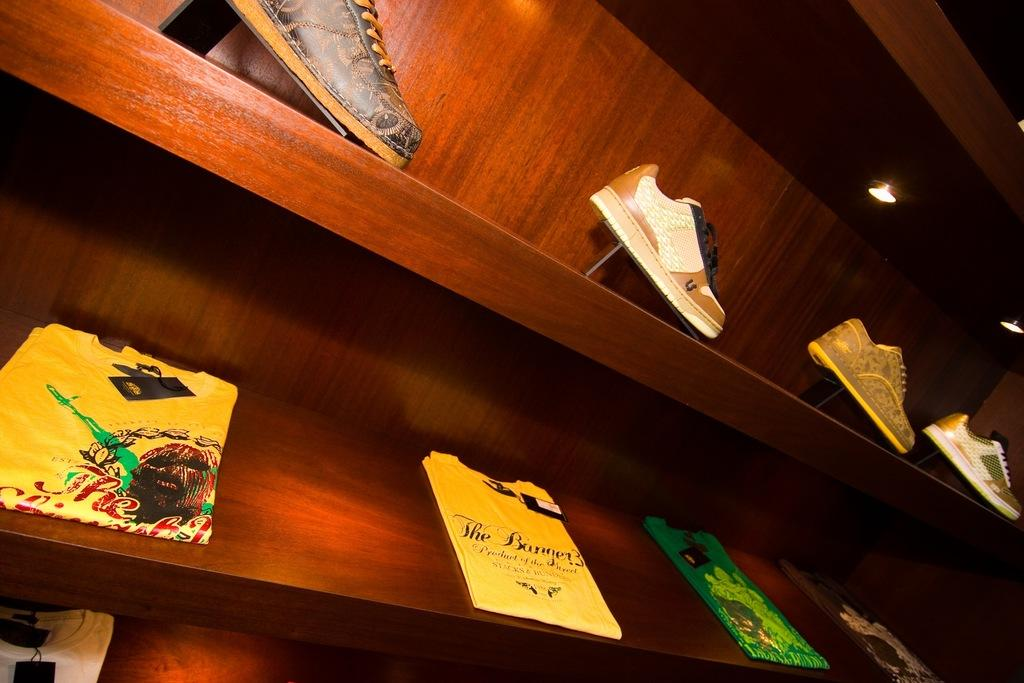What is the main object in the image? There is a rack in the image. What is stored on the rack? The rack contains shoes. What type of brush is used to clean the shoes on the rack? There is no brush present in the image, and the type of brush used to clean the shoes cannot be determined. 